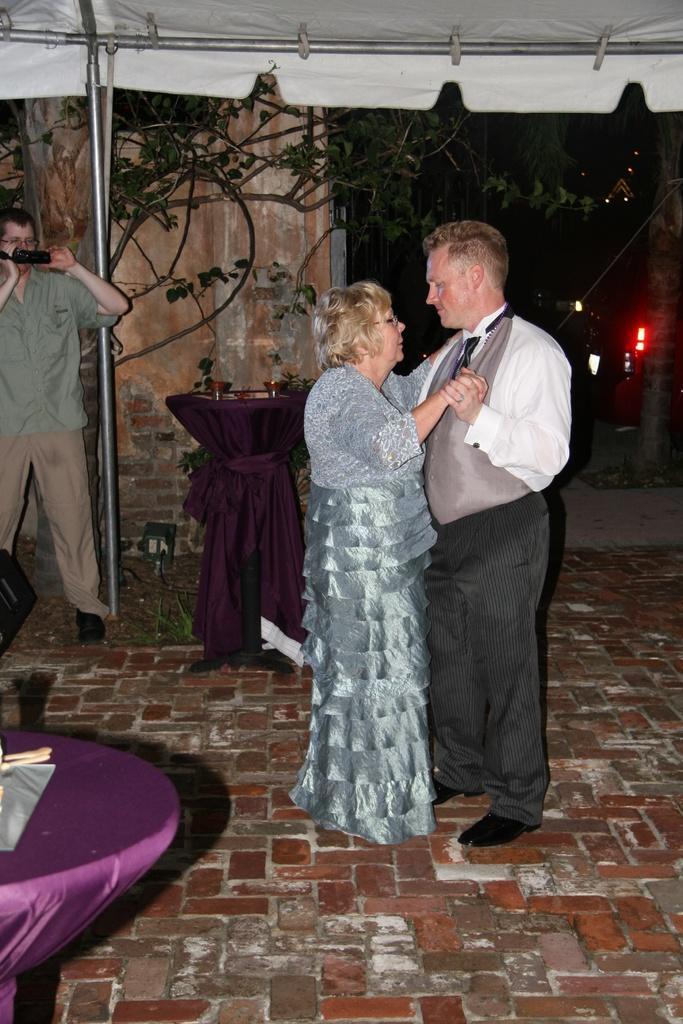How would you summarize this image in a sentence or two? In the image I can see couple dancing under the tent, beside that there are two tables and person holding camera. 